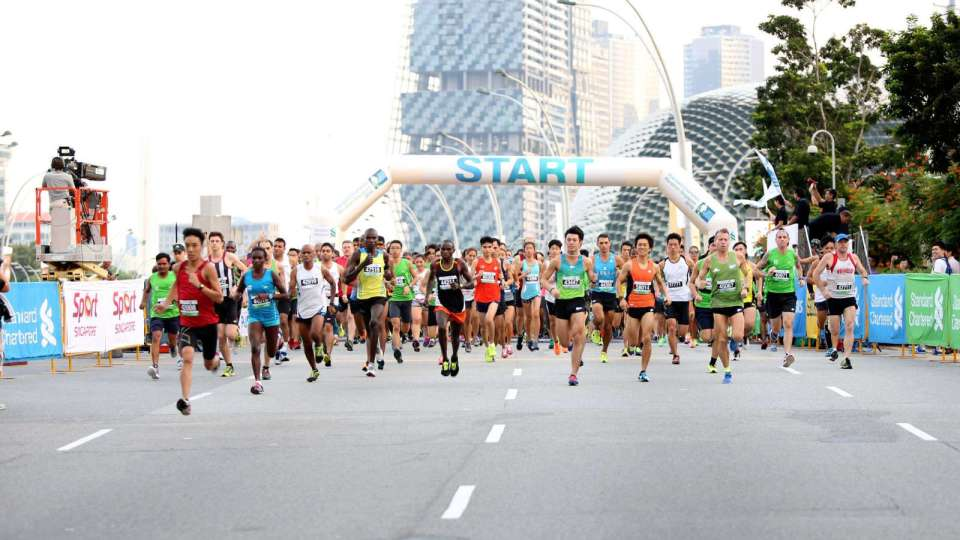What if this event is a futuristic race held in an imaginary city where runners compete with the aid of advanced technologies? In this futuristic race, runners are equipped with exo-suits that enhance their speed and endurance. The cityscape is a blend of towering skyscrapers with hovering drones broadcasting the event live. Each competitor's performance is monitored in real-time by AI trainers offering tactical advice through augmented reality interfaces, creating an exhilarating blend of athleticism and cutting-edge technology. Considering the advancements in technology seen in the race, what unique challenges or enhancements may the runners experience? Runners may face challenges such as navigating through dynamic, holographic obstacles and adapting to intelligent terrain that can alter its features to simulate varied racing conditions. On the flip side, enhancements like bio-sensors providing health metrics and personalized hydration packs delivering nutrients based on immediate needs could significantly optimize their performance and safety, making the race an extraordinary blend of human effort and technological innovation. 